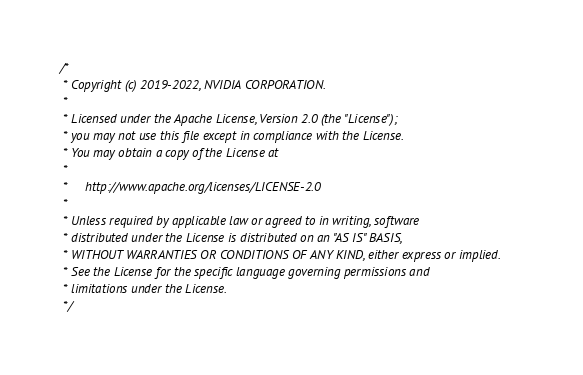Convert code to text. <code><loc_0><loc_0><loc_500><loc_500><_Cuda_>/*
 * Copyright (c) 2019-2022, NVIDIA CORPORATION.
 *
 * Licensed under the Apache License, Version 2.0 (the "License");
 * you may not use this file except in compliance with the License.
 * You may obtain a copy of the License at
 *
 *     http://www.apache.org/licenses/LICENSE-2.0
 *
 * Unless required by applicable law or agreed to in writing, software
 * distributed under the License is distributed on an "AS IS" BASIS,
 * WITHOUT WARRANTIES OR CONDITIONS OF ANY KIND, either express or implied.
 * See the License for the specific language governing permissions and
 * limitations under the License.
 */
</code> 